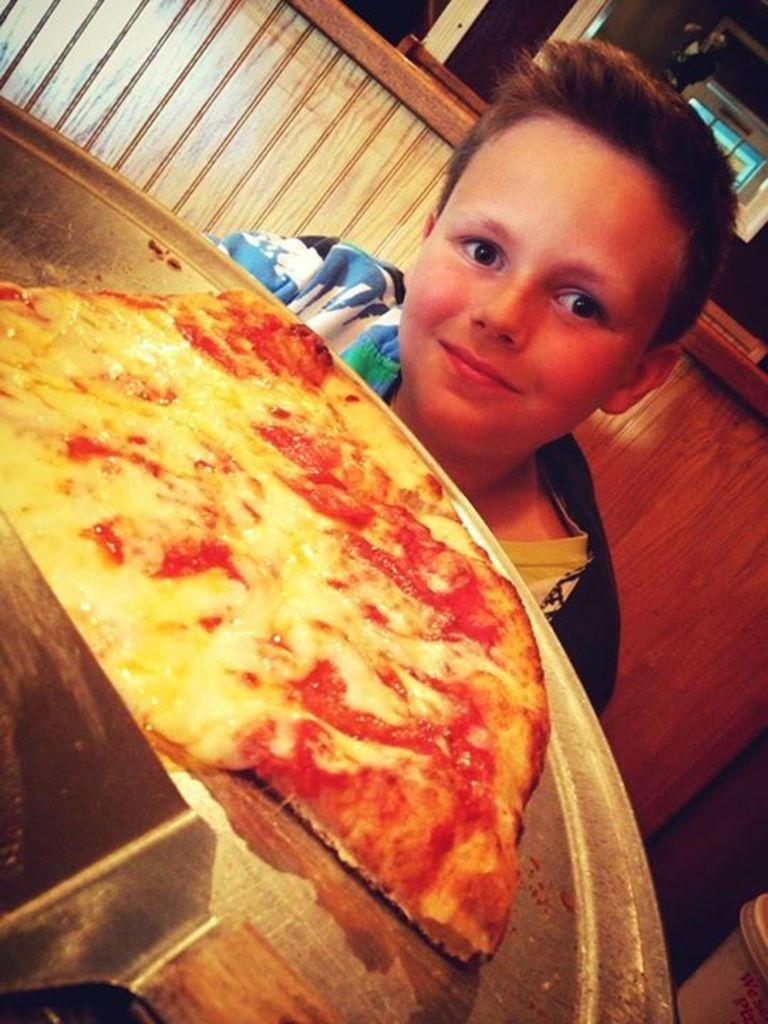What is the main subject of the image? There is a boy sitting in the image. What is the boy doing in the image? The boy is sitting. What can be seen on the plate in the image? There is a pizza on a plate in the image. What type of straw is the boy using to paddle the boat in the image? There is no boat or straw present in the image; it features a boy sitting and a pizza on a plate. 